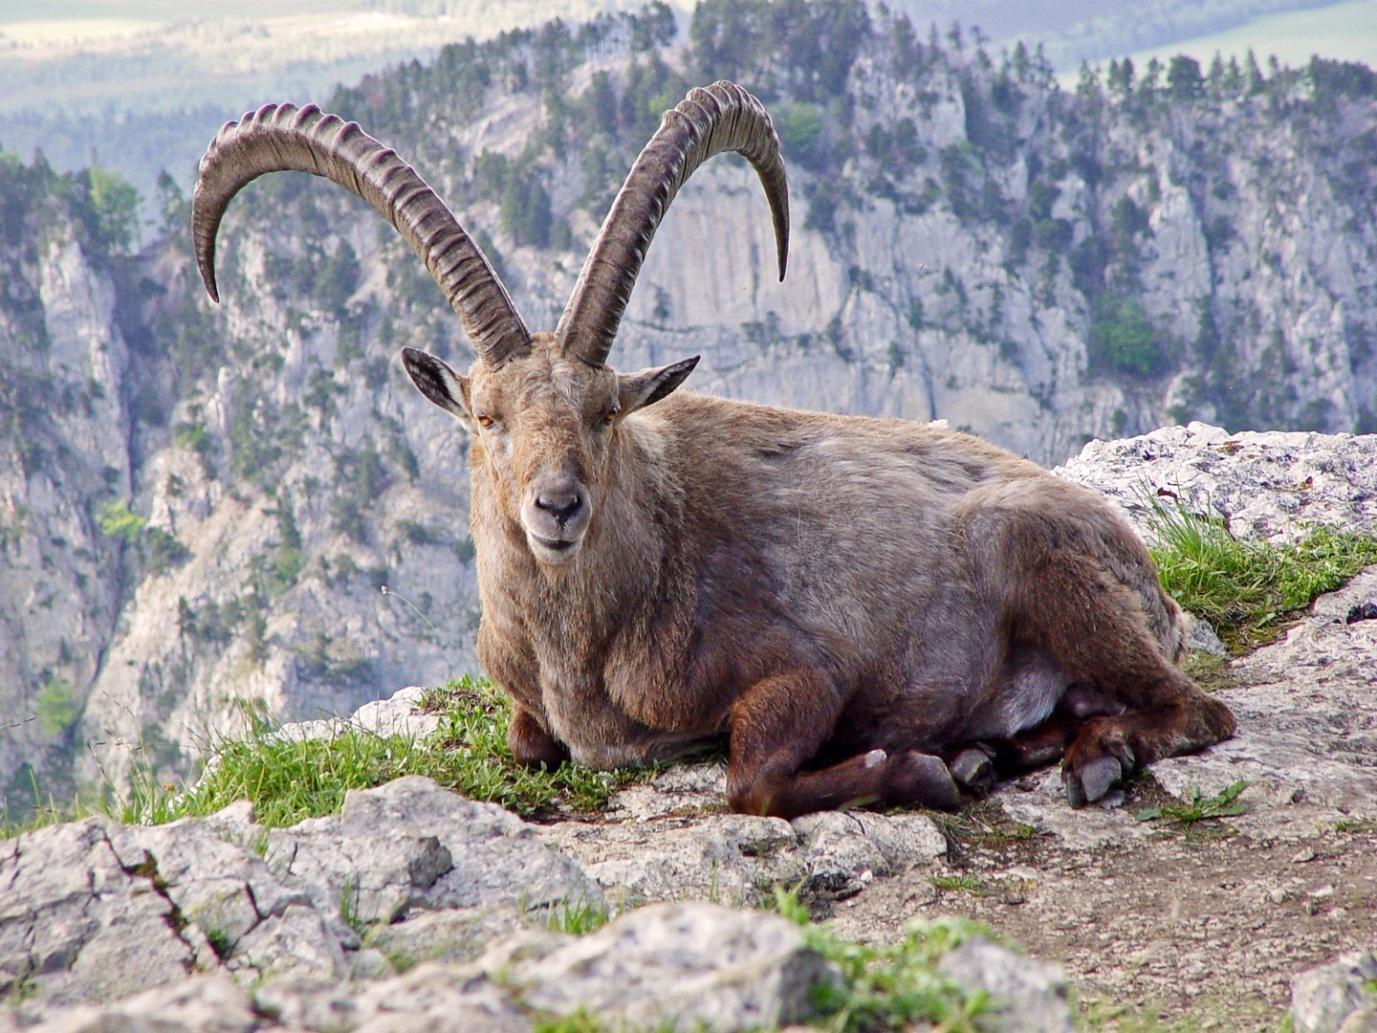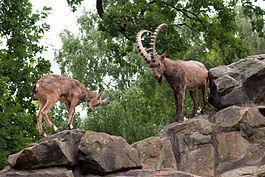The first image is the image on the left, the second image is the image on the right. For the images displayed, is the sentence "Each image contains just one horned animal, and one image shows an animal reclining on a rock, with large boulders behind it." factually correct? Answer yes or no. No. 